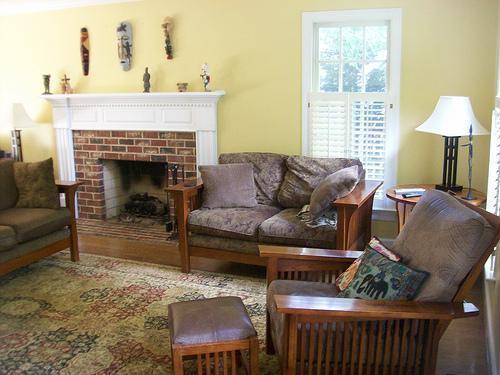How many pillows on chair?
Give a very brief answer. 2. 